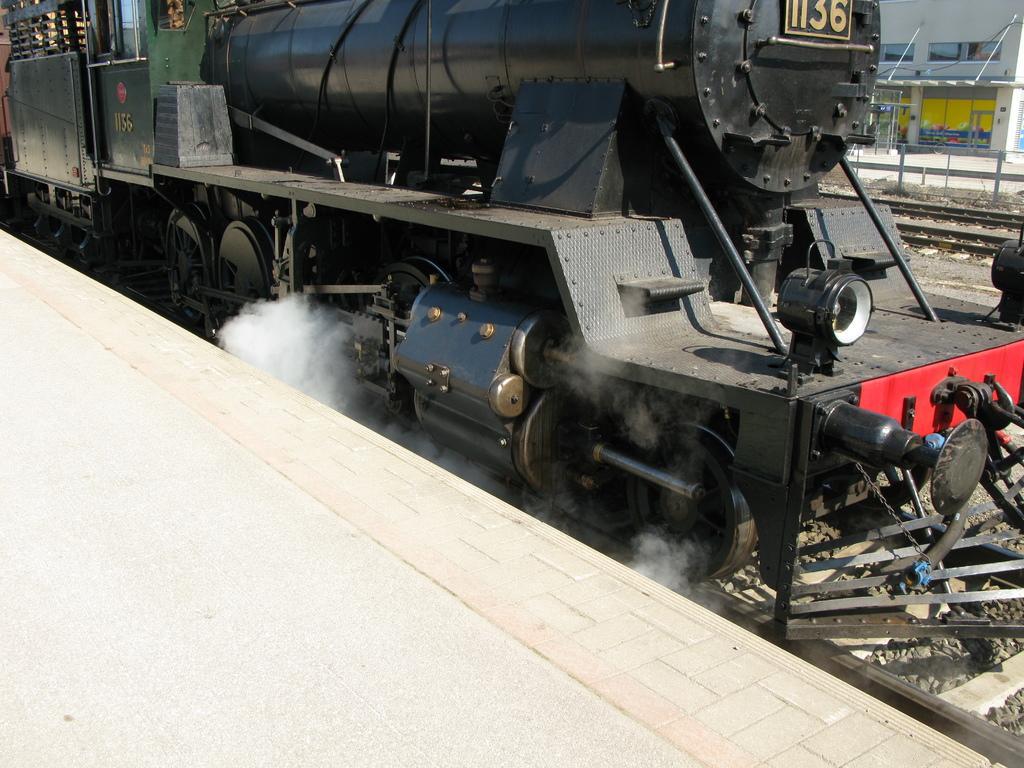Can you describe this image briefly? Here we can see a platform and a train on the railway track and we can see smoke at the wheels of a train. In the background on the left side we can see a building,windows,poles,metal objects on the floor,fence,railway track,grass and a platform. 